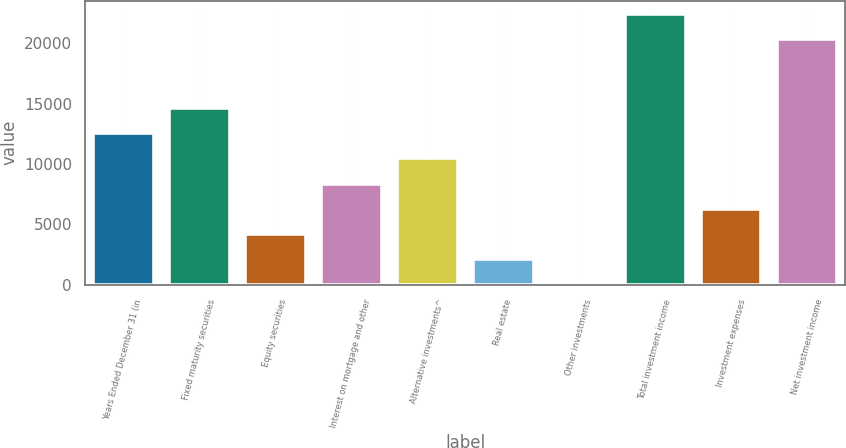<chart> <loc_0><loc_0><loc_500><loc_500><bar_chart><fcel>Years Ended December 31 (in<fcel>Fixed maturity securities<fcel>Equity securities<fcel>Interest on mortgage and other<fcel>Alternative investments^<fcel>Real estate<fcel>Other investments<fcel>Total investment income<fcel>Investment expenses<fcel>Net investment income<nl><fcel>12572.6<fcel>14666.2<fcel>4198.2<fcel>8385.4<fcel>10479<fcel>2104.6<fcel>11<fcel>22436.6<fcel>6291.8<fcel>20343<nl></chart> 